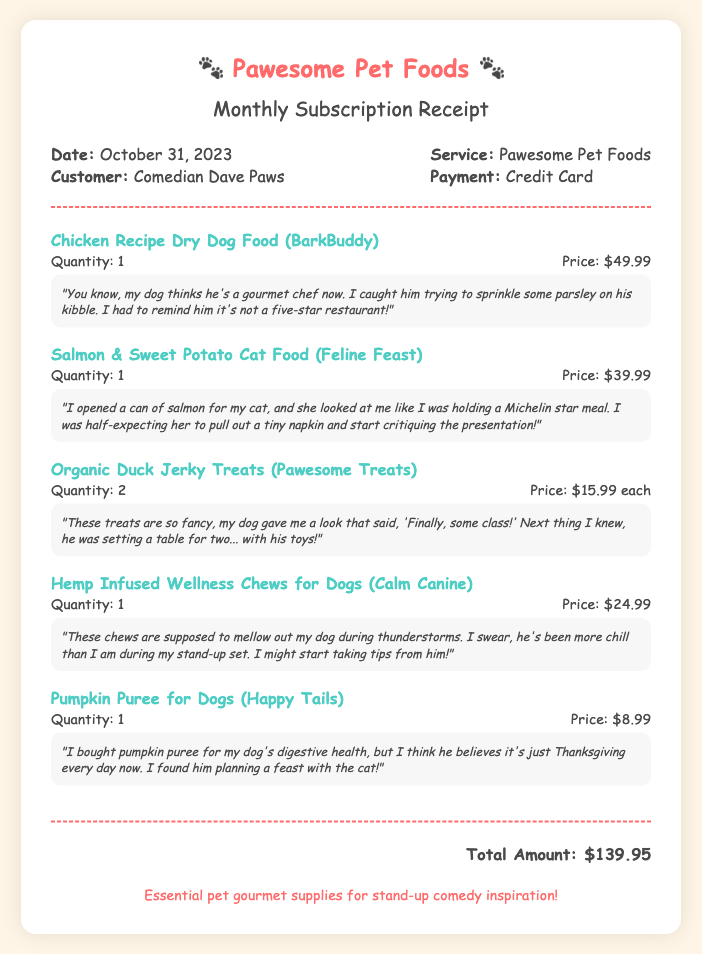What is the total amount? The total amount is listed at the bottom of the receipt indicating the final charge for the products purchased.
Answer: $139.95 What is the date of the receipt? The date is provided in the document to specify when the transaction took place.
Answer: October 31, 2023 Who is the customer? The customer's name appears in the document, showing who made the purchase.
Answer: Comedian Dave Paws How many types of dog food are mentioned? The document lists various food items; counting those specific to dogs will give the total.
Answer: 3 What is the price of the Organic Duck Jerky Treats? The price for this specific item is provided in the item details section.
Answer: $15.99 each What item is noted for calming dogs during thunderstorms? The document specifies a product designed to help dogs be more relaxed during stressful situations.
Answer: Hemp Infused Wellness Chews for Dogs What brand is the Chicken Recipe Dry Dog Food? Each product in the document is paired with its respective brand name, which can be found next to the product name.
Answer: BarkBuddy How many Salmon & Sweet Potato Cat Food were purchased? The quantity of this specific item is listed alongside its details to indicate how many were bought.
Answer: 1 